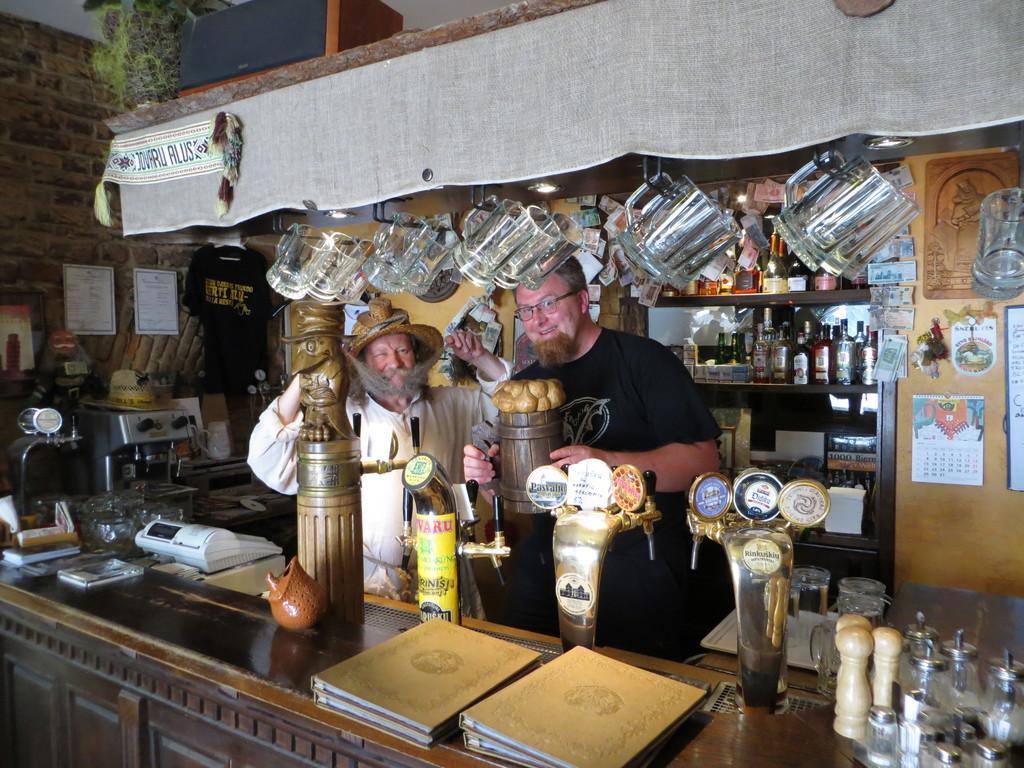Describe this image in one or two sentences. In this image there are two people standing with a smile on their face, one of the person is holding some object in his hand, in front of them on the table there are beer dispensers, books, vending machines, behind them there are bottles of whiskeys on the shelves, at the top of the image there are glasses hanging from the ceiling. 